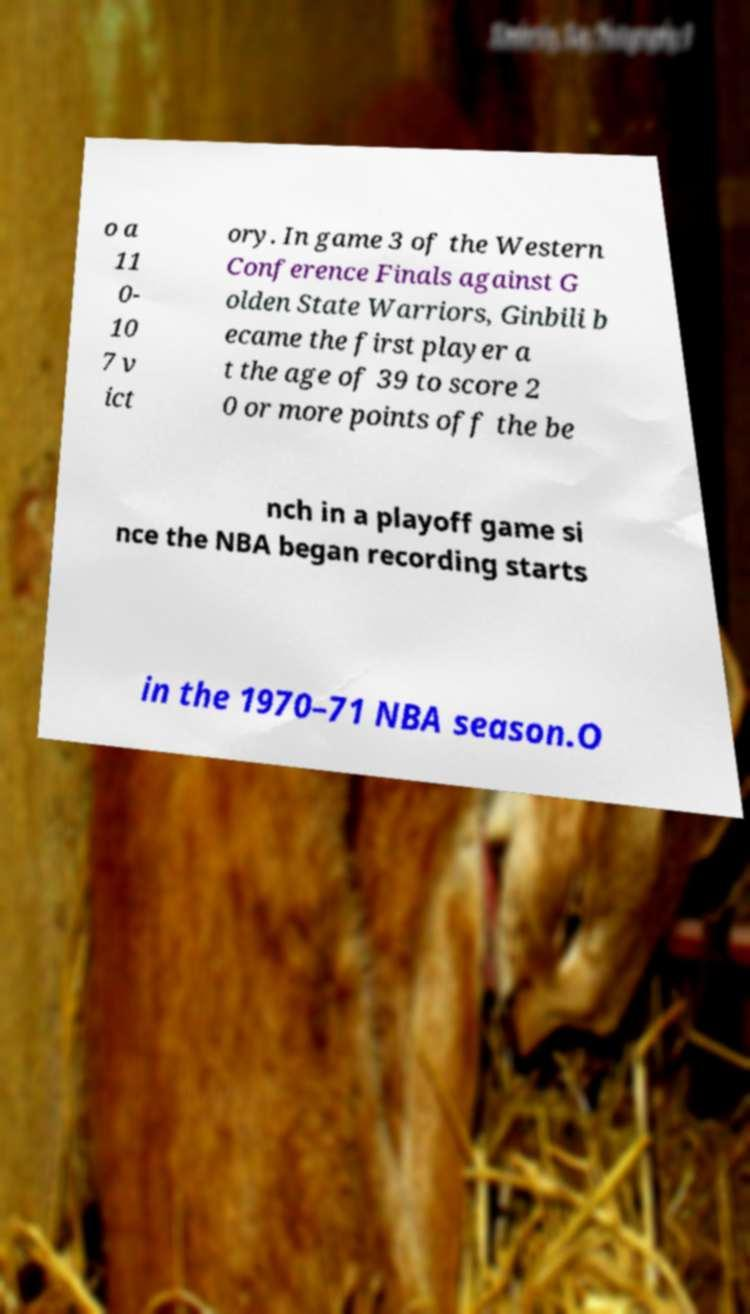What messages or text are displayed in this image? I need them in a readable, typed format. o a 11 0- 10 7 v ict ory. In game 3 of the Western Conference Finals against G olden State Warriors, Ginbili b ecame the first player a t the age of 39 to score 2 0 or more points off the be nch in a playoff game si nce the NBA began recording starts in the 1970–71 NBA season.O 